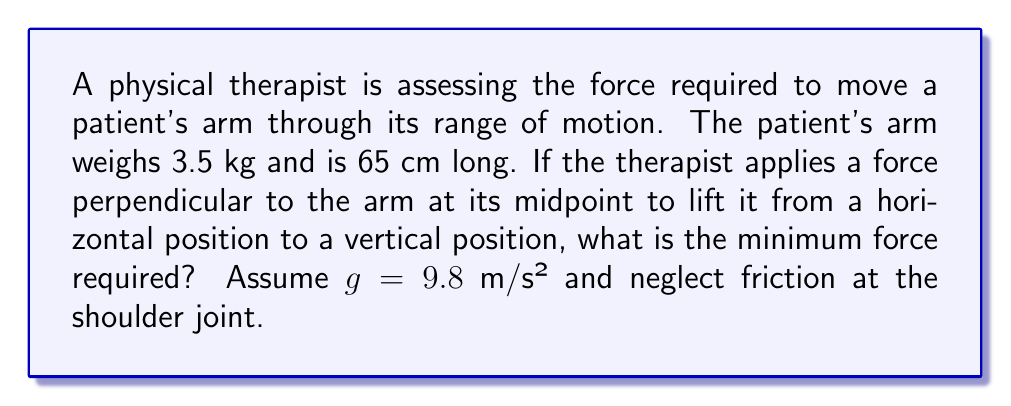What is the answer to this math problem? To solve this problem, we need to consider the torque required to lift the arm. The arm acts as a lever with its weight acting at its center of mass.

1. Calculate the torque due to the arm's weight:
   - The arm's weight: $W = mg = 3.5 \text{ kg} \times 9.8 \text{ m/s}^2 = 34.3 \text{ N}$
   - The lever arm for the weight is half the arm's length: $r_w = 65 \text{ cm} / 2 = 32.5 \text{ cm} = 0.325 \text{ m}$
   - Torque due to weight: $\tau_w = W \times r_w = 34.3 \text{ N} \times 0.325 \text{ m} = 11.15 \text{ N}\cdot\text{m}$

2. Set up the torque equation:
   - The applied force (F) acts at the midpoint of the arm, so its lever arm is also 0.325 m
   - For equilibrium: $\tau_{\text{applied}} = \tau_w$
   - $F \times 0.325 \text{ m} = 11.15 \text{ N}\cdot\text{m}$

3. Solve for the required force:
   $$F = \frac{11.15 \text{ N}\cdot\text{m}}{0.325 \text{ m}} = 34.3 \text{ N}$$

This is the minimum force required to lift the arm from a horizontal to a vertical position.
Answer: The minimum force required is 34.3 N. 